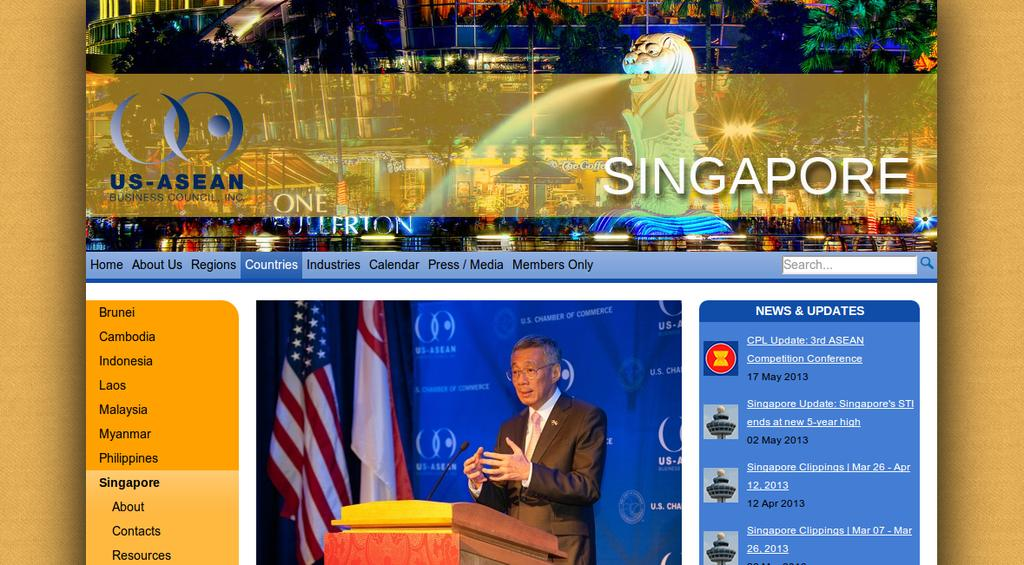<image>
Provide a brief description of the given image. A webpage showing a man behind a lectern with a banner over it that says Singapore. 